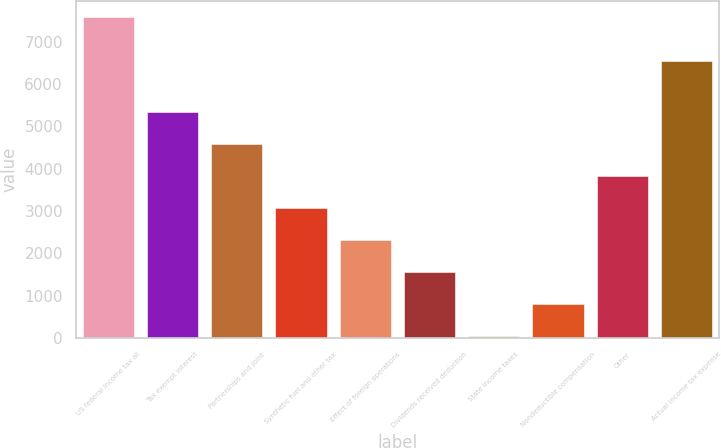Convert chart to OTSL. <chart><loc_0><loc_0><loc_500><loc_500><bar_chart><fcel>US federal income tax at<fcel>Tax exempt interest<fcel>Partnerships and joint<fcel>Synthetic fuel and other tax<fcel>Effect of foreign operations<fcel>Dividends received deduction<fcel>State income taxes<fcel>Nondeductible compensation<fcel>Other<fcel>Actual income tax expense<nl><fcel>7591<fcel>5331.4<fcel>4578.2<fcel>3071.8<fcel>2318.6<fcel>1565.4<fcel>59<fcel>812.2<fcel>3825<fcel>6537<nl></chart> 